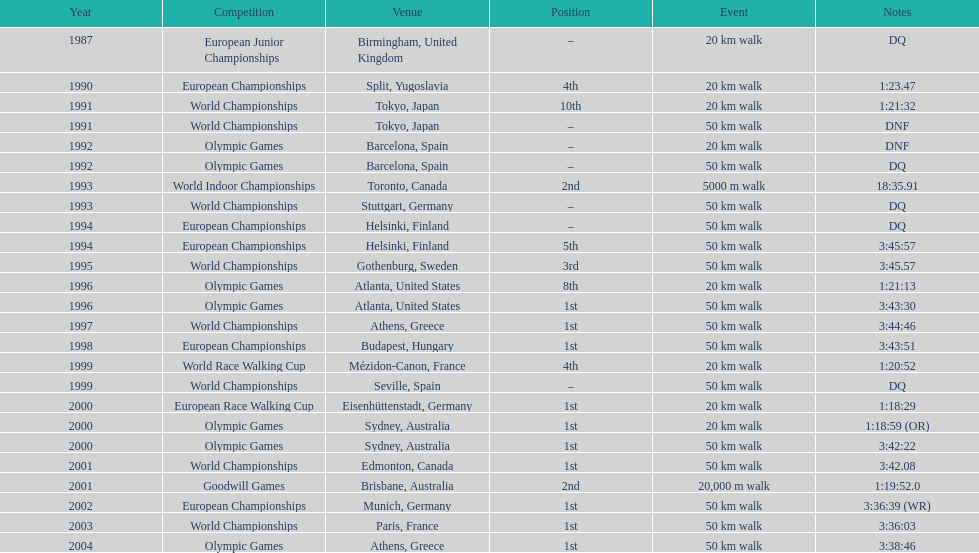In 1990 what position did robert korzeniowski place? 4th. In 1993 what was robert korzeniowski's place in the world indoor championships? 2nd. How long did the 50km walk in 2004 olympic cost? 3:38:46. 